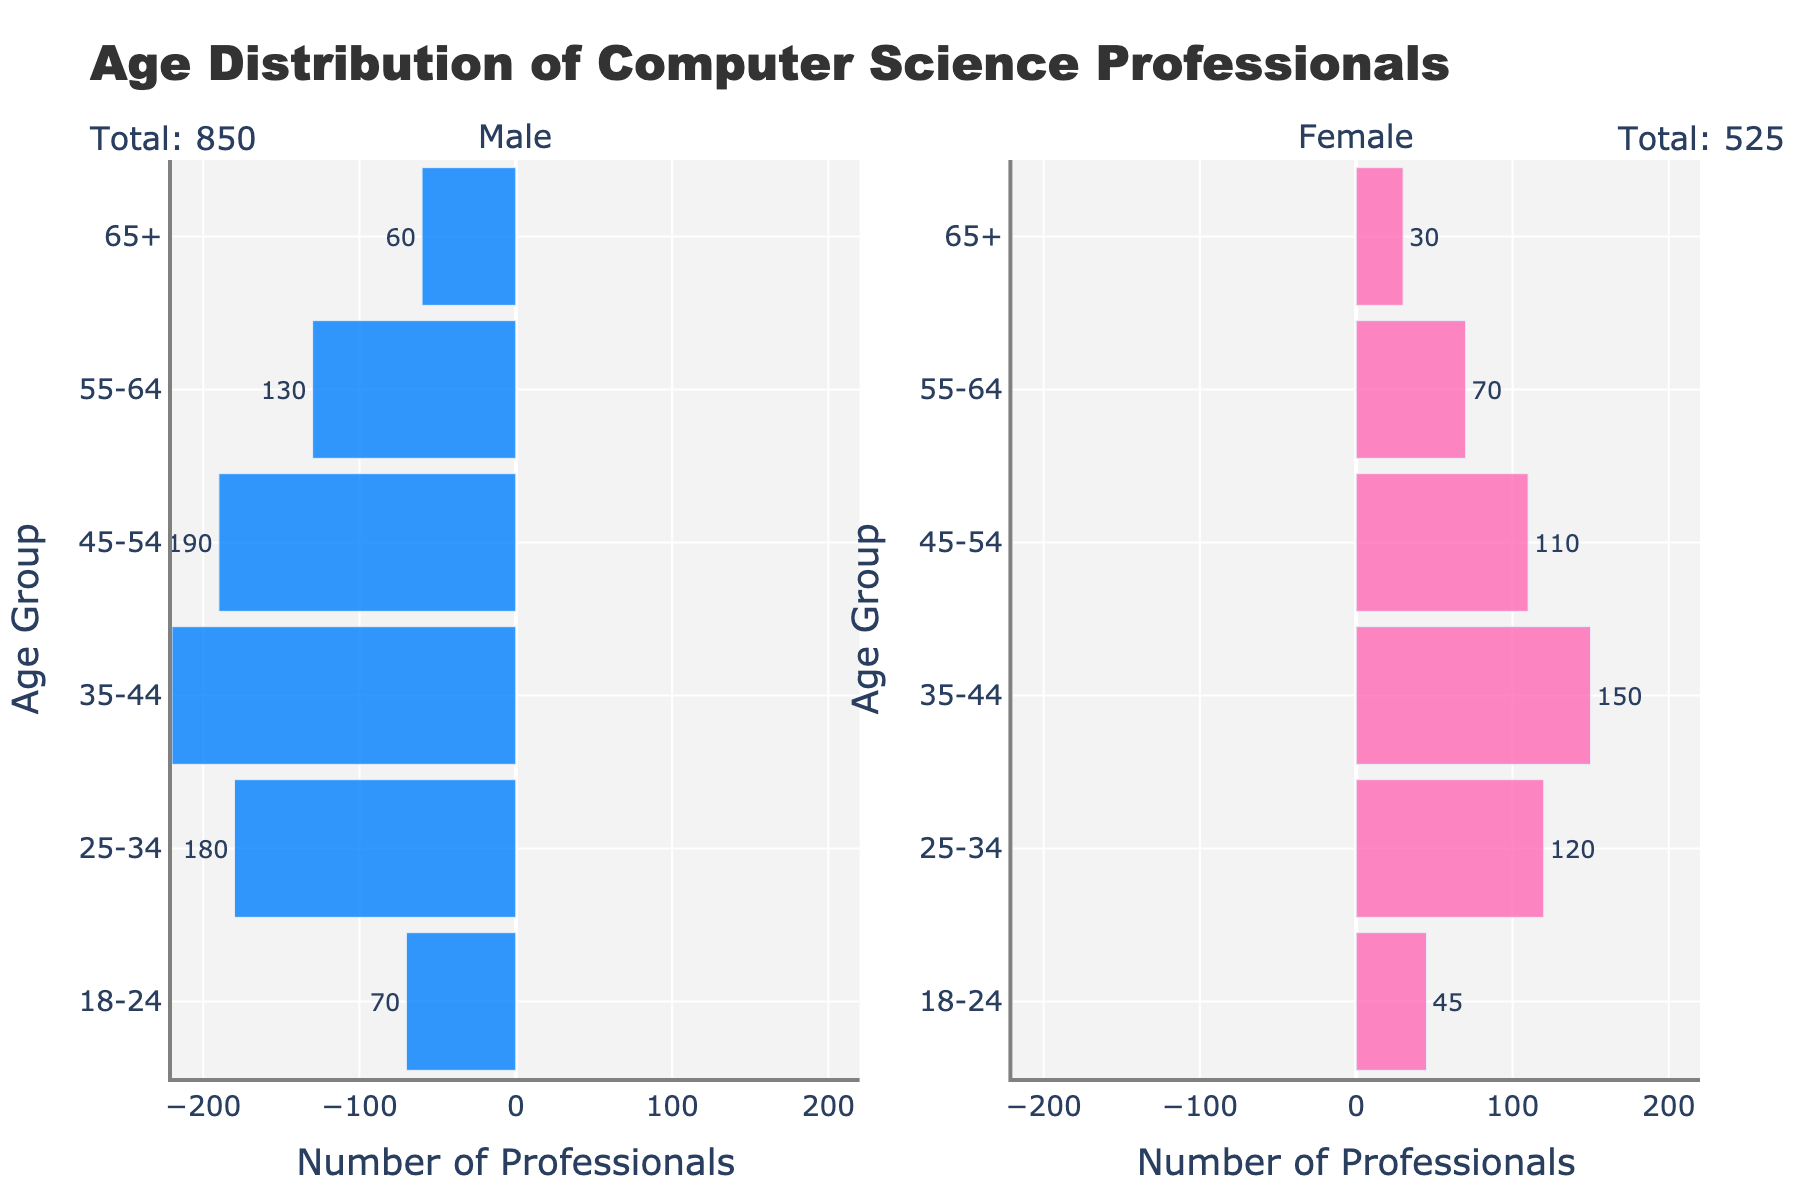what is the title of the figure? The title of the figure is prominently displayed at the top of the plot. It usually summarizes the purpose of the figure. Here, it directly states the content of the plot.
Answer: Age Distribution of Computer Science Professionals what age group has the highest number of male professionals? The age group with the highest number of male professionals is indicated by the largest bar on the left side of the plot for males.
Answer: 35-44 How many more males are there in the 35-44 age group compared to the 45-54 age group? Look at the bars for the 35-44 and 45-54 male age groups. The bars indicate 220 males in the 35-44 group and 190 in the 45-54 group. To find the difference, subtract the number in the 45-54 group from the 35-44 group: 220 - 190 = 30.
Answer: 30 Which age group has a higher number of females, 25-34 or 55-64? Compare the lengths of the bars on the right side of the pyramid for the 25-34 and 55-64 female age groups. The bar for the 25-34 group reaches 120, while the bar for the 55-64 group only reaches 70.
Answer: 25-34 Compare the total number of male and female computer science professionals. Who has a higher representation? Look at the annotations above each half of the plot showing the total counts. The male total is obtained by summing the absolute values of all male bars, and the female total is the sum of all female bars. From provided data, the male total is 850, and the female total is 525.
Answer: Males What is the second smallest age group of male professionals? By examining the lengths of the bars for males from shortest to longest, the smallest is the 65+ group, followed by the second shortest, which is the 18-24 group.
Answer: 18-24 what age group has the least number of female professionals? The age group with the least number of female professionals is indicated by the shortest bar on the right side of the plot for females.
Answer: 65+ What percentage of the total computer science professionals are females in the 35-44 age group? The bar for the 35-44 female age group indicates 150. The total number of professionals is 850 males + 525 females = 1375. To find the percentage, divide the number of females in the 35-44 age group by the total number of professionals and multiply by 100: (150 / 1375) * 100 ≈ 10.91%.
Answer: ≈10.91% How does the distribution of female professionals change with age? To answer this, look across the bars on the right side for females from youngest to oldest age groups. The plot shows that the number of female professionals decreases steadily with increasing age.
Answer: Decreases steadily What can be inferred about the trend of male professionals beyond the age of 45? Looking at the left side of the plot, the number of male professionals declines from 190 in the 45-54 group to 130 in the 55-64 group, and further to 60 in the 65+ group. This indicates a consistent decline.
Answer: Declines 